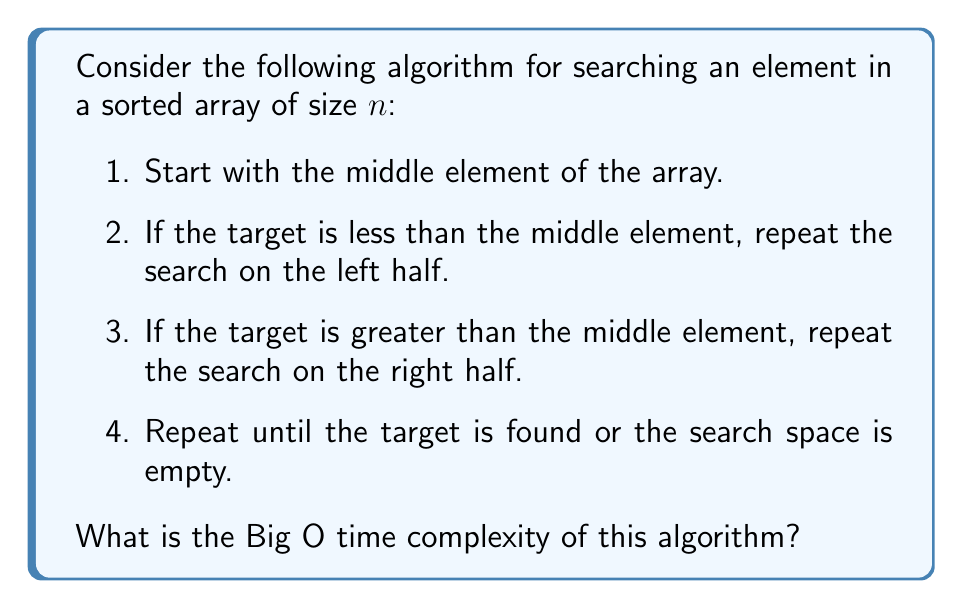What is the answer to this math problem? Let's analyze this algorithm step-by-step:

1) First, we recognize that this algorithm is a binary search implementation.

2) In each step, we're dividing the search space in half:
   - First iteration: $n$ elements
   - Second iteration: $\frac{n}{2}$ elements
   - Third iteration: $\frac{n}{4}$ elements
   - And so on...

3) We can express this as a series: $n, \frac{n}{2}, \frac{n}{4}, \frac{n}{8}, ..., 1$

4) The question is: how many times can we divide $n$ by 2 until we reach 1?

5) This can be expressed mathematically as:

   $$\frac{n}{2^k} = 1$$

   where $k$ is the number of steps.

6) Solving for $k$:
   
   $$n = 2^k$$
   $$\log_2(n) = \log_2(2^k)$$
   $$\log_2(n) = k$$

7) Therefore, the algorithm performs at most $\log_2(n)$ steps.

8) In Big O notation, we drop the base of the logarithm as it only affects the time complexity by a constant factor. Thus, we express this as $O(\log n)$.
Answer: $O(\log n)$ 